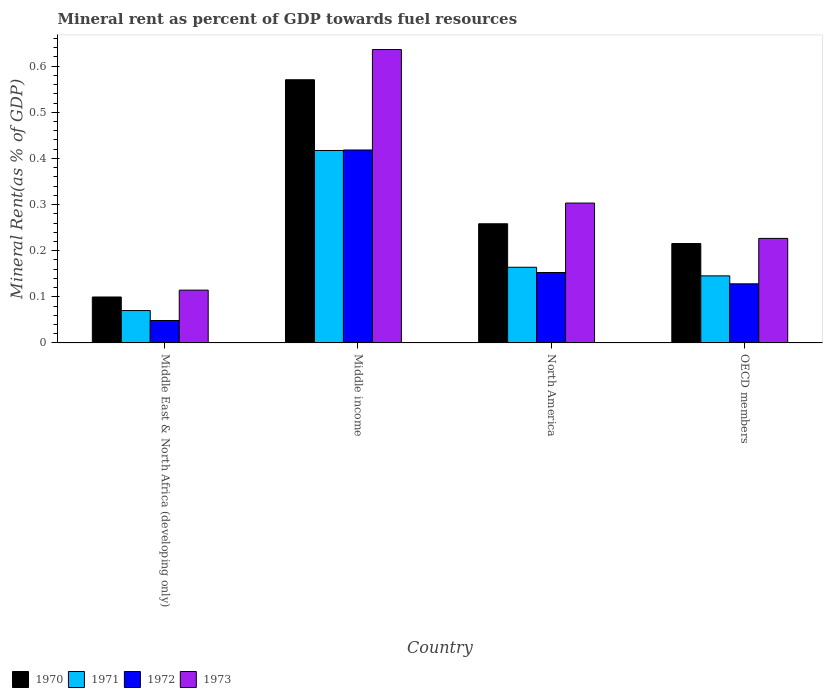How many different coloured bars are there?
Your response must be concise. 4. Are the number of bars on each tick of the X-axis equal?
Ensure brevity in your answer.  Yes. In how many cases, is the number of bars for a given country not equal to the number of legend labels?
Your answer should be very brief. 0. What is the mineral rent in 1973 in Middle East & North Africa (developing only)?
Provide a short and direct response. 0.11. Across all countries, what is the maximum mineral rent in 1971?
Keep it short and to the point. 0.42. Across all countries, what is the minimum mineral rent in 1971?
Give a very brief answer. 0.07. In which country was the mineral rent in 1970 minimum?
Make the answer very short. Middle East & North Africa (developing only). What is the total mineral rent in 1970 in the graph?
Your response must be concise. 1.14. What is the difference between the mineral rent in 1973 in Middle income and that in North America?
Offer a terse response. 0.33. What is the difference between the mineral rent in 1970 in Middle income and the mineral rent in 1972 in OECD members?
Provide a succinct answer. 0.44. What is the average mineral rent in 1972 per country?
Keep it short and to the point. 0.19. What is the difference between the mineral rent of/in 1970 and mineral rent of/in 1973 in Middle income?
Offer a very short reply. -0.07. What is the ratio of the mineral rent in 1971 in Middle East & North Africa (developing only) to that in OECD members?
Your answer should be very brief. 0.48. Is the mineral rent in 1970 in Middle income less than that in OECD members?
Provide a succinct answer. No. Is the difference between the mineral rent in 1970 in Middle East & North Africa (developing only) and OECD members greater than the difference between the mineral rent in 1973 in Middle East & North Africa (developing only) and OECD members?
Provide a short and direct response. No. What is the difference between the highest and the second highest mineral rent in 1971?
Ensure brevity in your answer.  0.27. What is the difference between the highest and the lowest mineral rent in 1971?
Provide a short and direct response. 0.35. Is it the case that in every country, the sum of the mineral rent in 1970 and mineral rent in 1971 is greater than the sum of mineral rent in 1973 and mineral rent in 1972?
Make the answer very short. No. What does the 2nd bar from the left in Middle East & North Africa (developing only) represents?
Ensure brevity in your answer.  1971. How many bars are there?
Your answer should be compact. 16. How many countries are there in the graph?
Ensure brevity in your answer.  4. Does the graph contain any zero values?
Provide a short and direct response. No. Where does the legend appear in the graph?
Your response must be concise. Bottom left. How are the legend labels stacked?
Keep it short and to the point. Horizontal. What is the title of the graph?
Your response must be concise. Mineral rent as percent of GDP towards fuel resources. Does "1975" appear as one of the legend labels in the graph?
Ensure brevity in your answer.  No. What is the label or title of the X-axis?
Ensure brevity in your answer.  Country. What is the label or title of the Y-axis?
Give a very brief answer. Mineral Rent(as % of GDP). What is the Mineral Rent(as % of GDP) of 1970 in Middle East & North Africa (developing only)?
Offer a very short reply. 0.1. What is the Mineral Rent(as % of GDP) of 1971 in Middle East & North Africa (developing only)?
Ensure brevity in your answer.  0.07. What is the Mineral Rent(as % of GDP) of 1972 in Middle East & North Africa (developing only)?
Your answer should be very brief. 0.05. What is the Mineral Rent(as % of GDP) in 1973 in Middle East & North Africa (developing only)?
Give a very brief answer. 0.11. What is the Mineral Rent(as % of GDP) in 1970 in Middle income?
Your answer should be very brief. 0.57. What is the Mineral Rent(as % of GDP) of 1971 in Middle income?
Your answer should be compact. 0.42. What is the Mineral Rent(as % of GDP) in 1972 in Middle income?
Keep it short and to the point. 0.42. What is the Mineral Rent(as % of GDP) in 1973 in Middle income?
Make the answer very short. 0.64. What is the Mineral Rent(as % of GDP) of 1970 in North America?
Your response must be concise. 0.26. What is the Mineral Rent(as % of GDP) in 1971 in North America?
Your response must be concise. 0.16. What is the Mineral Rent(as % of GDP) of 1972 in North America?
Provide a succinct answer. 0.15. What is the Mineral Rent(as % of GDP) of 1973 in North America?
Offer a very short reply. 0.3. What is the Mineral Rent(as % of GDP) of 1970 in OECD members?
Offer a very short reply. 0.22. What is the Mineral Rent(as % of GDP) of 1971 in OECD members?
Provide a short and direct response. 0.15. What is the Mineral Rent(as % of GDP) of 1972 in OECD members?
Your answer should be very brief. 0.13. What is the Mineral Rent(as % of GDP) in 1973 in OECD members?
Your answer should be compact. 0.23. Across all countries, what is the maximum Mineral Rent(as % of GDP) in 1970?
Make the answer very short. 0.57. Across all countries, what is the maximum Mineral Rent(as % of GDP) in 1971?
Give a very brief answer. 0.42. Across all countries, what is the maximum Mineral Rent(as % of GDP) in 1972?
Make the answer very short. 0.42. Across all countries, what is the maximum Mineral Rent(as % of GDP) in 1973?
Your answer should be compact. 0.64. Across all countries, what is the minimum Mineral Rent(as % of GDP) in 1970?
Your answer should be very brief. 0.1. Across all countries, what is the minimum Mineral Rent(as % of GDP) of 1971?
Give a very brief answer. 0.07. Across all countries, what is the minimum Mineral Rent(as % of GDP) of 1972?
Ensure brevity in your answer.  0.05. Across all countries, what is the minimum Mineral Rent(as % of GDP) of 1973?
Keep it short and to the point. 0.11. What is the total Mineral Rent(as % of GDP) in 1970 in the graph?
Make the answer very short. 1.14. What is the total Mineral Rent(as % of GDP) in 1971 in the graph?
Ensure brevity in your answer.  0.8. What is the total Mineral Rent(as % of GDP) in 1972 in the graph?
Keep it short and to the point. 0.75. What is the total Mineral Rent(as % of GDP) in 1973 in the graph?
Keep it short and to the point. 1.28. What is the difference between the Mineral Rent(as % of GDP) of 1970 in Middle East & North Africa (developing only) and that in Middle income?
Provide a succinct answer. -0.47. What is the difference between the Mineral Rent(as % of GDP) of 1971 in Middle East & North Africa (developing only) and that in Middle income?
Your answer should be very brief. -0.35. What is the difference between the Mineral Rent(as % of GDP) in 1972 in Middle East & North Africa (developing only) and that in Middle income?
Keep it short and to the point. -0.37. What is the difference between the Mineral Rent(as % of GDP) in 1973 in Middle East & North Africa (developing only) and that in Middle income?
Provide a succinct answer. -0.52. What is the difference between the Mineral Rent(as % of GDP) in 1970 in Middle East & North Africa (developing only) and that in North America?
Ensure brevity in your answer.  -0.16. What is the difference between the Mineral Rent(as % of GDP) of 1971 in Middle East & North Africa (developing only) and that in North America?
Your response must be concise. -0.09. What is the difference between the Mineral Rent(as % of GDP) in 1972 in Middle East & North Africa (developing only) and that in North America?
Ensure brevity in your answer.  -0.1. What is the difference between the Mineral Rent(as % of GDP) of 1973 in Middle East & North Africa (developing only) and that in North America?
Provide a short and direct response. -0.19. What is the difference between the Mineral Rent(as % of GDP) of 1970 in Middle East & North Africa (developing only) and that in OECD members?
Offer a terse response. -0.12. What is the difference between the Mineral Rent(as % of GDP) of 1971 in Middle East & North Africa (developing only) and that in OECD members?
Offer a very short reply. -0.08. What is the difference between the Mineral Rent(as % of GDP) in 1972 in Middle East & North Africa (developing only) and that in OECD members?
Provide a short and direct response. -0.08. What is the difference between the Mineral Rent(as % of GDP) in 1973 in Middle East & North Africa (developing only) and that in OECD members?
Your response must be concise. -0.11. What is the difference between the Mineral Rent(as % of GDP) of 1970 in Middle income and that in North America?
Your answer should be very brief. 0.31. What is the difference between the Mineral Rent(as % of GDP) in 1971 in Middle income and that in North America?
Your response must be concise. 0.25. What is the difference between the Mineral Rent(as % of GDP) of 1972 in Middle income and that in North America?
Your answer should be compact. 0.27. What is the difference between the Mineral Rent(as % of GDP) of 1973 in Middle income and that in North America?
Provide a succinct answer. 0.33. What is the difference between the Mineral Rent(as % of GDP) in 1970 in Middle income and that in OECD members?
Your answer should be compact. 0.35. What is the difference between the Mineral Rent(as % of GDP) of 1971 in Middle income and that in OECD members?
Your response must be concise. 0.27. What is the difference between the Mineral Rent(as % of GDP) in 1972 in Middle income and that in OECD members?
Your response must be concise. 0.29. What is the difference between the Mineral Rent(as % of GDP) of 1973 in Middle income and that in OECD members?
Provide a succinct answer. 0.41. What is the difference between the Mineral Rent(as % of GDP) of 1970 in North America and that in OECD members?
Provide a succinct answer. 0.04. What is the difference between the Mineral Rent(as % of GDP) in 1971 in North America and that in OECD members?
Ensure brevity in your answer.  0.02. What is the difference between the Mineral Rent(as % of GDP) of 1972 in North America and that in OECD members?
Make the answer very short. 0.02. What is the difference between the Mineral Rent(as % of GDP) in 1973 in North America and that in OECD members?
Offer a very short reply. 0.08. What is the difference between the Mineral Rent(as % of GDP) in 1970 in Middle East & North Africa (developing only) and the Mineral Rent(as % of GDP) in 1971 in Middle income?
Offer a very short reply. -0.32. What is the difference between the Mineral Rent(as % of GDP) in 1970 in Middle East & North Africa (developing only) and the Mineral Rent(as % of GDP) in 1972 in Middle income?
Your answer should be very brief. -0.32. What is the difference between the Mineral Rent(as % of GDP) in 1970 in Middle East & North Africa (developing only) and the Mineral Rent(as % of GDP) in 1973 in Middle income?
Provide a succinct answer. -0.54. What is the difference between the Mineral Rent(as % of GDP) in 1971 in Middle East & North Africa (developing only) and the Mineral Rent(as % of GDP) in 1972 in Middle income?
Offer a terse response. -0.35. What is the difference between the Mineral Rent(as % of GDP) in 1971 in Middle East & North Africa (developing only) and the Mineral Rent(as % of GDP) in 1973 in Middle income?
Your response must be concise. -0.57. What is the difference between the Mineral Rent(as % of GDP) of 1972 in Middle East & North Africa (developing only) and the Mineral Rent(as % of GDP) of 1973 in Middle income?
Keep it short and to the point. -0.59. What is the difference between the Mineral Rent(as % of GDP) of 1970 in Middle East & North Africa (developing only) and the Mineral Rent(as % of GDP) of 1971 in North America?
Provide a succinct answer. -0.06. What is the difference between the Mineral Rent(as % of GDP) in 1970 in Middle East & North Africa (developing only) and the Mineral Rent(as % of GDP) in 1972 in North America?
Your answer should be very brief. -0.05. What is the difference between the Mineral Rent(as % of GDP) in 1970 in Middle East & North Africa (developing only) and the Mineral Rent(as % of GDP) in 1973 in North America?
Ensure brevity in your answer.  -0.2. What is the difference between the Mineral Rent(as % of GDP) of 1971 in Middle East & North Africa (developing only) and the Mineral Rent(as % of GDP) of 1972 in North America?
Give a very brief answer. -0.08. What is the difference between the Mineral Rent(as % of GDP) in 1971 in Middle East & North Africa (developing only) and the Mineral Rent(as % of GDP) in 1973 in North America?
Provide a succinct answer. -0.23. What is the difference between the Mineral Rent(as % of GDP) of 1972 in Middle East & North Africa (developing only) and the Mineral Rent(as % of GDP) of 1973 in North America?
Your answer should be very brief. -0.25. What is the difference between the Mineral Rent(as % of GDP) of 1970 in Middle East & North Africa (developing only) and the Mineral Rent(as % of GDP) of 1971 in OECD members?
Keep it short and to the point. -0.05. What is the difference between the Mineral Rent(as % of GDP) in 1970 in Middle East & North Africa (developing only) and the Mineral Rent(as % of GDP) in 1972 in OECD members?
Keep it short and to the point. -0.03. What is the difference between the Mineral Rent(as % of GDP) in 1970 in Middle East & North Africa (developing only) and the Mineral Rent(as % of GDP) in 1973 in OECD members?
Your answer should be very brief. -0.13. What is the difference between the Mineral Rent(as % of GDP) in 1971 in Middle East & North Africa (developing only) and the Mineral Rent(as % of GDP) in 1972 in OECD members?
Offer a very short reply. -0.06. What is the difference between the Mineral Rent(as % of GDP) of 1971 in Middle East & North Africa (developing only) and the Mineral Rent(as % of GDP) of 1973 in OECD members?
Offer a terse response. -0.16. What is the difference between the Mineral Rent(as % of GDP) in 1972 in Middle East & North Africa (developing only) and the Mineral Rent(as % of GDP) in 1973 in OECD members?
Give a very brief answer. -0.18. What is the difference between the Mineral Rent(as % of GDP) in 1970 in Middle income and the Mineral Rent(as % of GDP) in 1971 in North America?
Offer a terse response. 0.41. What is the difference between the Mineral Rent(as % of GDP) in 1970 in Middle income and the Mineral Rent(as % of GDP) in 1972 in North America?
Your answer should be compact. 0.42. What is the difference between the Mineral Rent(as % of GDP) of 1970 in Middle income and the Mineral Rent(as % of GDP) of 1973 in North America?
Offer a very short reply. 0.27. What is the difference between the Mineral Rent(as % of GDP) of 1971 in Middle income and the Mineral Rent(as % of GDP) of 1972 in North America?
Provide a succinct answer. 0.26. What is the difference between the Mineral Rent(as % of GDP) of 1971 in Middle income and the Mineral Rent(as % of GDP) of 1973 in North America?
Provide a succinct answer. 0.11. What is the difference between the Mineral Rent(as % of GDP) of 1972 in Middle income and the Mineral Rent(as % of GDP) of 1973 in North America?
Offer a terse response. 0.12. What is the difference between the Mineral Rent(as % of GDP) of 1970 in Middle income and the Mineral Rent(as % of GDP) of 1971 in OECD members?
Give a very brief answer. 0.43. What is the difference between the Mineral Rent(as % of GDP) in 1970 in Middle income and the Mineral Rent(as % of GDP) in 1972 in OECD members?
Offer a very short reply. 0.44. What is the difference between the Mineral Rent(as % of GDP) in 1970 in Middle income and the Mineral Rent(as % of GDP) in 1973 in OECD members?
Provide a short and direct response. 0.34. What is the difference between the Mineral Rent(as % of GDP) in 1971 in Middle income and the Mineral Rent(as % of GDP) in 1972 in OECD members?
Ensure brevity in your answer.  0.29. What is the difference between the Mineral Rent(as % of GDP) of 1971 in Middle income and the Mineral Rent(as % of GDP) of 1973 in OECD members?
Keep it short and to the point. 0.19. What is the difference between the Mineral Rent(as % of GDP) in 1972 in Middle income and the Mineral Rent(as % of GDP) in 1973 in OECD members?
Keep it short and to the point. 0.19. What is the difference between the Mineral Rent(as % of GDP) of 1970 in North America and the Mineral Rent(as % of GDP) of 1971 in OECD members?
Provide a short and direct response. 0.11. What is the difference between the Mineral Rent(as % of GDP) of 1970 in North America and the Mineral Rent(as % of GDP) of 1972 in OECD members?
Your answer should be compact. 0.13. What is the difference between the Mineral Rent(as % of GDP) of 1970 in North America and the Mineral Rent(as % of GDP) of 1973 in OECD members?
Give a very brief answer. 0.03. What is the difference between the Mineral Rent(as % of GDP) in 1971 in North America and the Mineral Rent(as % of GDP) in 1972 in OECD members?
Give a very brief answer. 0.04. What is the difference between the Mineral Rent(as % of GDP) in 1971 in North America and the Mineral Rent(as % of GDP) in 1973 in OECD members?
Give a very brief answer. -0.06. What is the difference between the Mineral Rent(as % of GDP) in 1972 in North America and the Mineral Rent(as % of GDP) in 1973 in OECD members?
Keep it short and to the point. -0.07. What is the average Mineral Rent(as % of GDP) in 1970 per country?
Make the answer very short. 0.29. What is the average Mineral Rent(as % of GDP) of 1971 per country?
Provide a short and direct response. 0.2. What is the average Mineral Rent(as % of GDP) in 1972 per country?
Ensure brevity in your answer.  0.19. What is the average Mineral Rent(as % of GDP) of 1973 per country?
Your answer should be compact. 0.32. What is the difference between the Mineral Rent(as % of GDP) of 1970 and Mineral Rent(as % of GDP) of 1971 in Middle East & North Africa (developing only)?
Offer a terse response. 0.03. What is the difference between the Mineral Rent(as % of GDP) of 1970 and Mineral Rent(as % of GDP) of 1972 in Middle East & North Africa (developing only)?
Make the answer very short. 0.05. What is the difference between the Mineral Rent(as % of GDP) in 1970 and Mineral Rent(as % of GDP) in 1973 in Middle East & North Africa (developing only)?
Your response must be concise. -0.01. What is the difference between the Mineral Rent(as % of GDP) of 1971 and Mineral Rent(as % of GDP) of 1972 in Middle East & North Africa (developing only)?
Provide a succinct answer. 0.02. What is the difference between the Mineral Rent(as % of GDP) in 1971 and Mineral Rent(as % of GDP) in 1973 in Middle East & North Africa (developing only)?
Your answer should be very brief. -0.04. What is the difference between the Mineral Rent(as % of GDP) in 1972 and Mineral Rent(as % of GDP) in 1973 in Middle East & North Africa (developing only)?
Keep it short and to the point. -0.07. What is the difference between the Mineral Rent(as % of GDP) of 1970 and Mineral Rent(as % of GDP) of 1971 in Middle income?
Make the answer very short. 0.15. What is the difference between the Mineral Rent(as % of GDP) in 1970 and Mineral Rent(as % of GDP) in 1972 in Middle income?
Offer a terse response. 0.15. What is the difference between the Mineral Rent(as % of GDP) in 1970 and Mineral Rent(as % of GDP) in 1973 in Middle income?
Provide a succinct answer. -0.07. What is the difference between the Mineral Rent(as % of GDP) in 1971 and Mineral Rent(as % of GDP) in 1972 in Middle income?
Your answer should be compact. -0. What is the difference between the Mineral Rent(as % of GDP) of 1971 and Mineral Rent(as % of GDP) of 1973 in Middle income?
Give a very brief answer. -0.22. What is the difference between the Mineral Rent(as % of GDP) of 1972 and Mineral Rent(as % of GDP) of 1973 in Middle income?
Make the answer very short. -0.22. What is the difference between the Mineral Rent(as % of GDP) in 1970 and Mineral Rent(as % of GDP) in 1971 in North America?
Provide a succinct answer. 0.09. What is the difference between the Mineral Rent(as % of GDP) in 1970 and Mineral Rent(as % of GDP) in 1972 in North America?
Offer a terse response. 0.11. What is the difference between the Mineral Rent(as % of GDP) in 1970 and Mineral Rent(as % of GDP) in 1973 in North America?
Your answer should be very brief. -0.04. What is the difference between the Mineral Rent(as % of GDP) of 1971 and Mineral Rent(as % of GDP) of 1972 in North America?
Keep it short and to the point. 0.01. What is the difference between the Mineral Rent(as % of GDP) of 1971 and Mineral Rent(as % of GDP) of 1973 in North America?
Offer a terse response. -0.14. What is the difference between the Mineral Rent(as % of GDP) in 1972 and Mineral Rent(as % of GDP) in 1973 in North America?
Keep it short and to the point. -0.15. What is the difference between the Mineral Rent(as % of GDP) of 1970 and Mineral Rent(as % of GDP) of 1971 in OECD members?
Your answer should be very brief. 0.07. What is the difference between the Mineral Rent(as % of GDP) in 1970 and Mineral Rent(as % of GDP) in 1972 in OECD members?
Your response must be concise. 0.09. What is the difference between the Mineral Rent(as % of GDP) of 1970 and Mineral Rent(as % of GDP) of 1973 in OECD members?
Provide a succinct answer. -0.01. What is the difference between the Mineral Rent(as % of GDP) in 1971 and Mineral Rent(as % of GDP) in 1972 in OECD members?
Your response must be concise. 0.02. What is the difference between the Mineral Rent(as % of GDP) of 1971 and Mineral Rent(as % of GDP) of 1973 in OECD members?
Provide a short and direct response. -0.08. What is the difference between the Mineral Rent(as % of GDP) in 1972 and Mineral Rent(as % of GDP) in 1973 in OECD members?
Offer a terse response. -0.1. What is the ratio of the Mineral Rent(as % of GDP) in 1970 in Middle East & North Africa (developing only) to that in Middle income?
Make the answer very short. 0.17. What is the ratio of the Mineral Rent(as % of GDP) of 1971 in Middle East & North Africa (developing only) to that in Middle income?
Keep it short and to the point. 0.17. What is the ratio of the Mineral Rent(as % of GDP) of 1972 in Middle East & North Africa (developing only) to that in Middle income?
Provide a succinct answer. 0.12. What is the ratio of the Mineral Rent(as % of GDP) of 1973 in Middle East & North Africa (developing only) to that in Middle income?
Provide a succinct answer. 0.18. What is the ratio of the Mineral Rent(as % of GDP) in 1970 in Middle East & North Africa (developing only) to that in North America?
Offer a very short reply. 0.39. What is the ratio of the Mineral Rent(as % of GDP) in 1971 in Middle East & North Africa (developing only) to that in North America?
Provide a short and direct response. 0.43. What is the ratio of the Mineral Rent(as % of GDP) of 1972 in Middle East & North Africa (developing only) to that in North America?
Keep it short and to the point. 0.32. What is the ratio of the Mineral Rent(as % of GDP) in 1973 in Middle East & North Africa (developing only) to that in North America?
Offer a very short reply. 0.38. What is the ratio of the Mineral Rent(as % of GDP) in 1970 in Middle East & North Africa (developing only) to that in OECD members?
Offer a very short reply. 0.46. What is the ratio of the Mineral Rent(as % of GDP) of 1971 in Middle East & North Africa (developing only) to that in OECD members?
Give a very brief answer. 0.48. What is the ratio of the Mineral Rent(as % of GDP) of 1972 in Middle East & North Africa (developing only) to that in OECD members?
Your response must be concise. 0.38. What is the ratio of the Mineral Rent(as % of GDP) in 1973 in Middle East & North Africa (developing only) to that in OECD members?
Give a very brief answer. 0.51. What is the ratio of the Mineral Rent(as % of GDP) in 1970 in Middle income to that in North America?
Provide a succinct answer. 2.21. What is the ratio of the Mineral Rent(as % of GDP) in 1971 in Middle income to that in North America?
Keep it short and to the point. 2.54. What is the ratio of the Mineral Rent(as % of GDP) of 1972 in Middle income to that in North America?
Make the answer very short. 2.74. What is the ratio of the Mineral Rent(as % of GDP) of 1973 in Middle income to that in North America?
Keep it short and to the point. 2.1. What is the ratio of the Mineral Rent(as % of GDP) in 1970 in Middle income to that in OECD members?
Your response must be concise. 2.65. What is the ratio of the Mineral Rent(as % of GDP) of 1971 in Middle income to that in OECD members?
Keep it short and to the point. 2.87. What is the ratio of the Mineral Rent(as % of GDP) of 1972 in Middle income to that in OECD members?
Offer a very short reply. 3.26. What is the ratio of the Mineral Rent(as % of GDP) of 1973 in Middle income to that in OECD members?
Your response must be concise. 2.81. What is the ratio of the Mineral Rent(as % of GDP) in 1970 in North America to that in OECD members?
Your answer should be very brief. 1.2. What is the ratio of the Mineral Rent(as % of GDP) in 1971 in North America to that in OECD members?
Make the answer very short. 1.13. What is the ratio of the Mineral Rent(as % of GDP) in 1972 in North America to that in OECD members?
Give a very brief answer. 1.19. What is the ratio of the Mineral Rent(as % of GDP) in 1973 in North America to that in OECD members?
Keep it short and to the point. 1.34. What is the difference between the highest and the second highest Mineral Rent(as % of GDP) of 1970?
Your answer should be compact. 0.31. What is the difference between the highest and the second highest Mineral Rent(as % of GDP) of 1971?
Provide a short and direct response. 0.25. What is the difference between the highest and the second highest Mineral Rent(as % of GDP) in 1972?
Your answer should be very brief. 0.27. What is the difference between the highest and the second highest Mineral Rent(as % of GDP) in 1973?
Offer a very short reply. 0.33. What is the difference between the highest and the lowest Mineral Rent(as % of GDP) of 1970?
Give a very brief answer. 0.47. What is the difference between the highest and the lowest Mineral Rent(as % of GDP) of 1971?
Give a very brief answer. 0.35. What is the difference between the highest and the lowest Mineral Rent(as % of GDP) in 1972?
Provide a short and direct response. 0.37. What is the difference between the highest and the lowest Mineral Rent(as % of GDP) in 1973?
Provide a short and direct response. 0.52. 